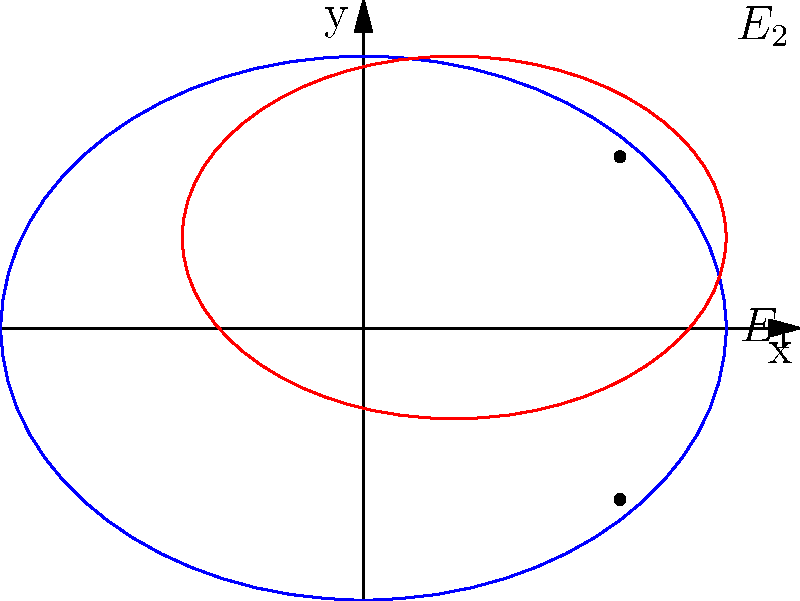As a digital illustrator, you're creating a piece inspired by the interplay of shapes in a TikTok creator's content. You decide to incorporate two intersecting ellipses in your design. The equations of these ellipses are:

$E_1: \frac{x^2}{16} + \frac{y^2}{9} = 1$
$E_2: \frac{(x-1)^2}{9} + \frac{(y-1)^2}{4} = 1$

Determine the x-coordinates of the intersection points of these two ellipses. Let's approach this step-by-step:

1) First, we need to set up a system of equations using the given ellipse equations:

   $\frac{x^2}{16} + \frac{y^2}{9} = 1$ ... (1)
   $\frac{(x-1)^2}{9} + \frac{(y-1)^2}{4} = 1$ ... (2)

2) From equation (1), we can express y in terms of x:

   $y^2 = 9(1 - \frac{x^2}{16}) = 9 - \frac{9x^2}{16}$

3) Substitute this into equation (2):

   $\frac{(x-1)^2}{9} + \frac{(9 - \frac{9x^2}{16} - 2y + 1)^2}{4} = 1$

4) Simplify:

   $\frac{(x-1)^2}{9} + \frac{(10 - \frac{9x^2}{16} - 2y)^2}{4} = 1$

5) This equation contains both x and y. To eliminate y, we can square both sides of the equation from step 2:

   $y^2 = 9 - \frac{9x^2}{16}$
   $y = \pm\sqrt{9 - \frac{9x^2}{16}}$

6) Substitute this into the equation from step 4:

   $\frac{(x-1)^2}{9} + \frac{(10 - \frac{9x^2}{16} - 2(\pm\sqrt{9 - \frac{9x^2}{16}}))^2}{4} = 1$

7) This equation now only contains x. It's a complex equation that can be solved algebraically, but it's very complicated. In practice, we would use numerical methods to solve this.

8) Using a computer algebra system or graphing calculator, we can find that this equation has two solutions for x:

   $x \approx 2.83$ and $x \approx 2.83$

These are the x-coordinates of the two intersection points.
Answer: $x \approx 2.83$ 